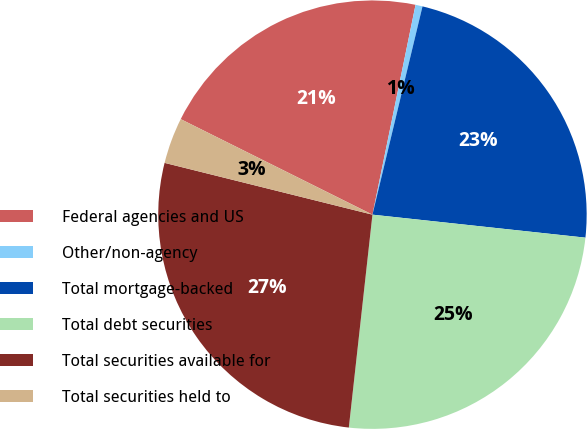Convert chart to OTSL. <chart><loc_0><loc_0><loc_500><loc_500><pie_chart><fcel>Federal agencies and US<fcel>Other/non-agency<fcel>Total mortgage-backed<fcel>Total debt securities<fcel>Total securities available for<fcel>Total securities held to<nl><fcel>20.87%<fcel>0.53%<fcel>22.96%<fcel>25.05%<fcel>27.13%<fcel>3.47%<nl></chart> 